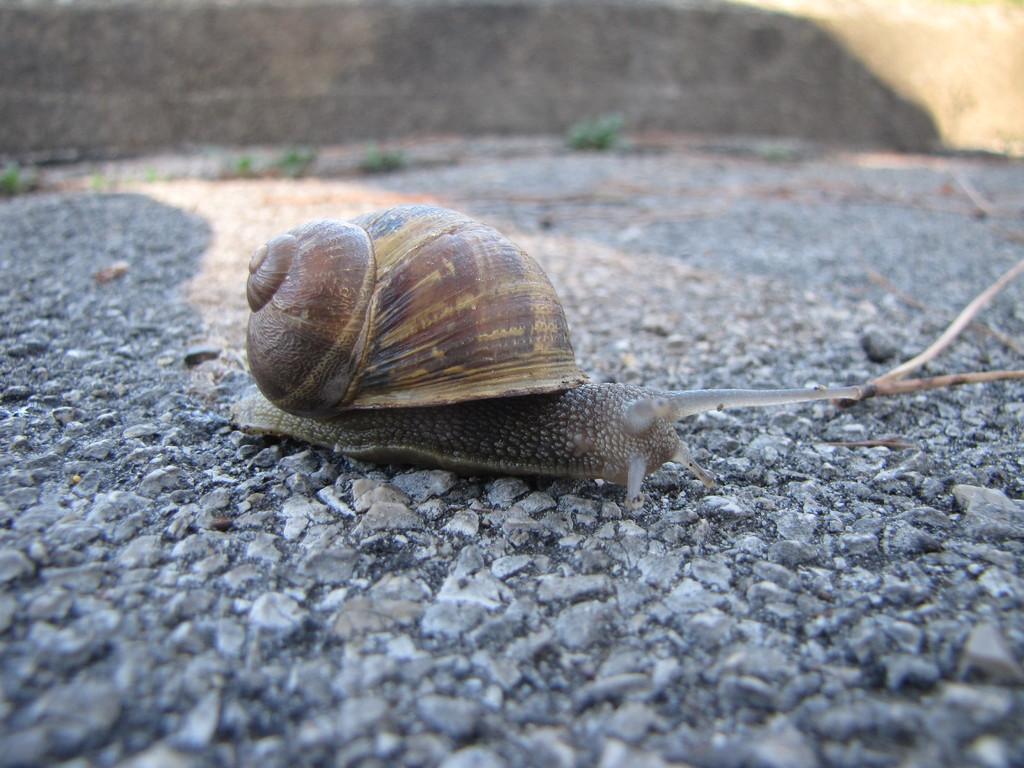Could you give a brief overview of what you see in this image? In the picture I can see a snail on the ground. The background of the image is blurred. 